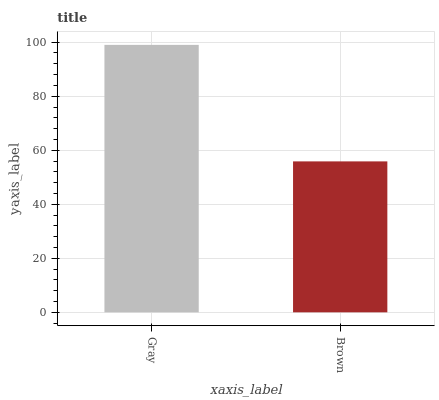Is Brown the minimum?
Answer yes or no. Yes. Is Gray the maximum?
Answer yes or no. Yes. Is Brown the maximum?
Answer yes or no. No. Is Gray greater than Brown?
Answer yes or no. Yes. Is Brown less than Gray?
Answer yes or no. Yes. Is Brown greater than Gray?
Answer yes or no. No. Is Gray less than Brown?
Answer yes or no. No. Is Gray the high median?
Answer yes or no. Yes. Is Brown the low median?
Answer yes or no. Yes. Is Brown the high median?
Answer yes or no. No. Is Gray the low median?
Answer yes or no. No. 